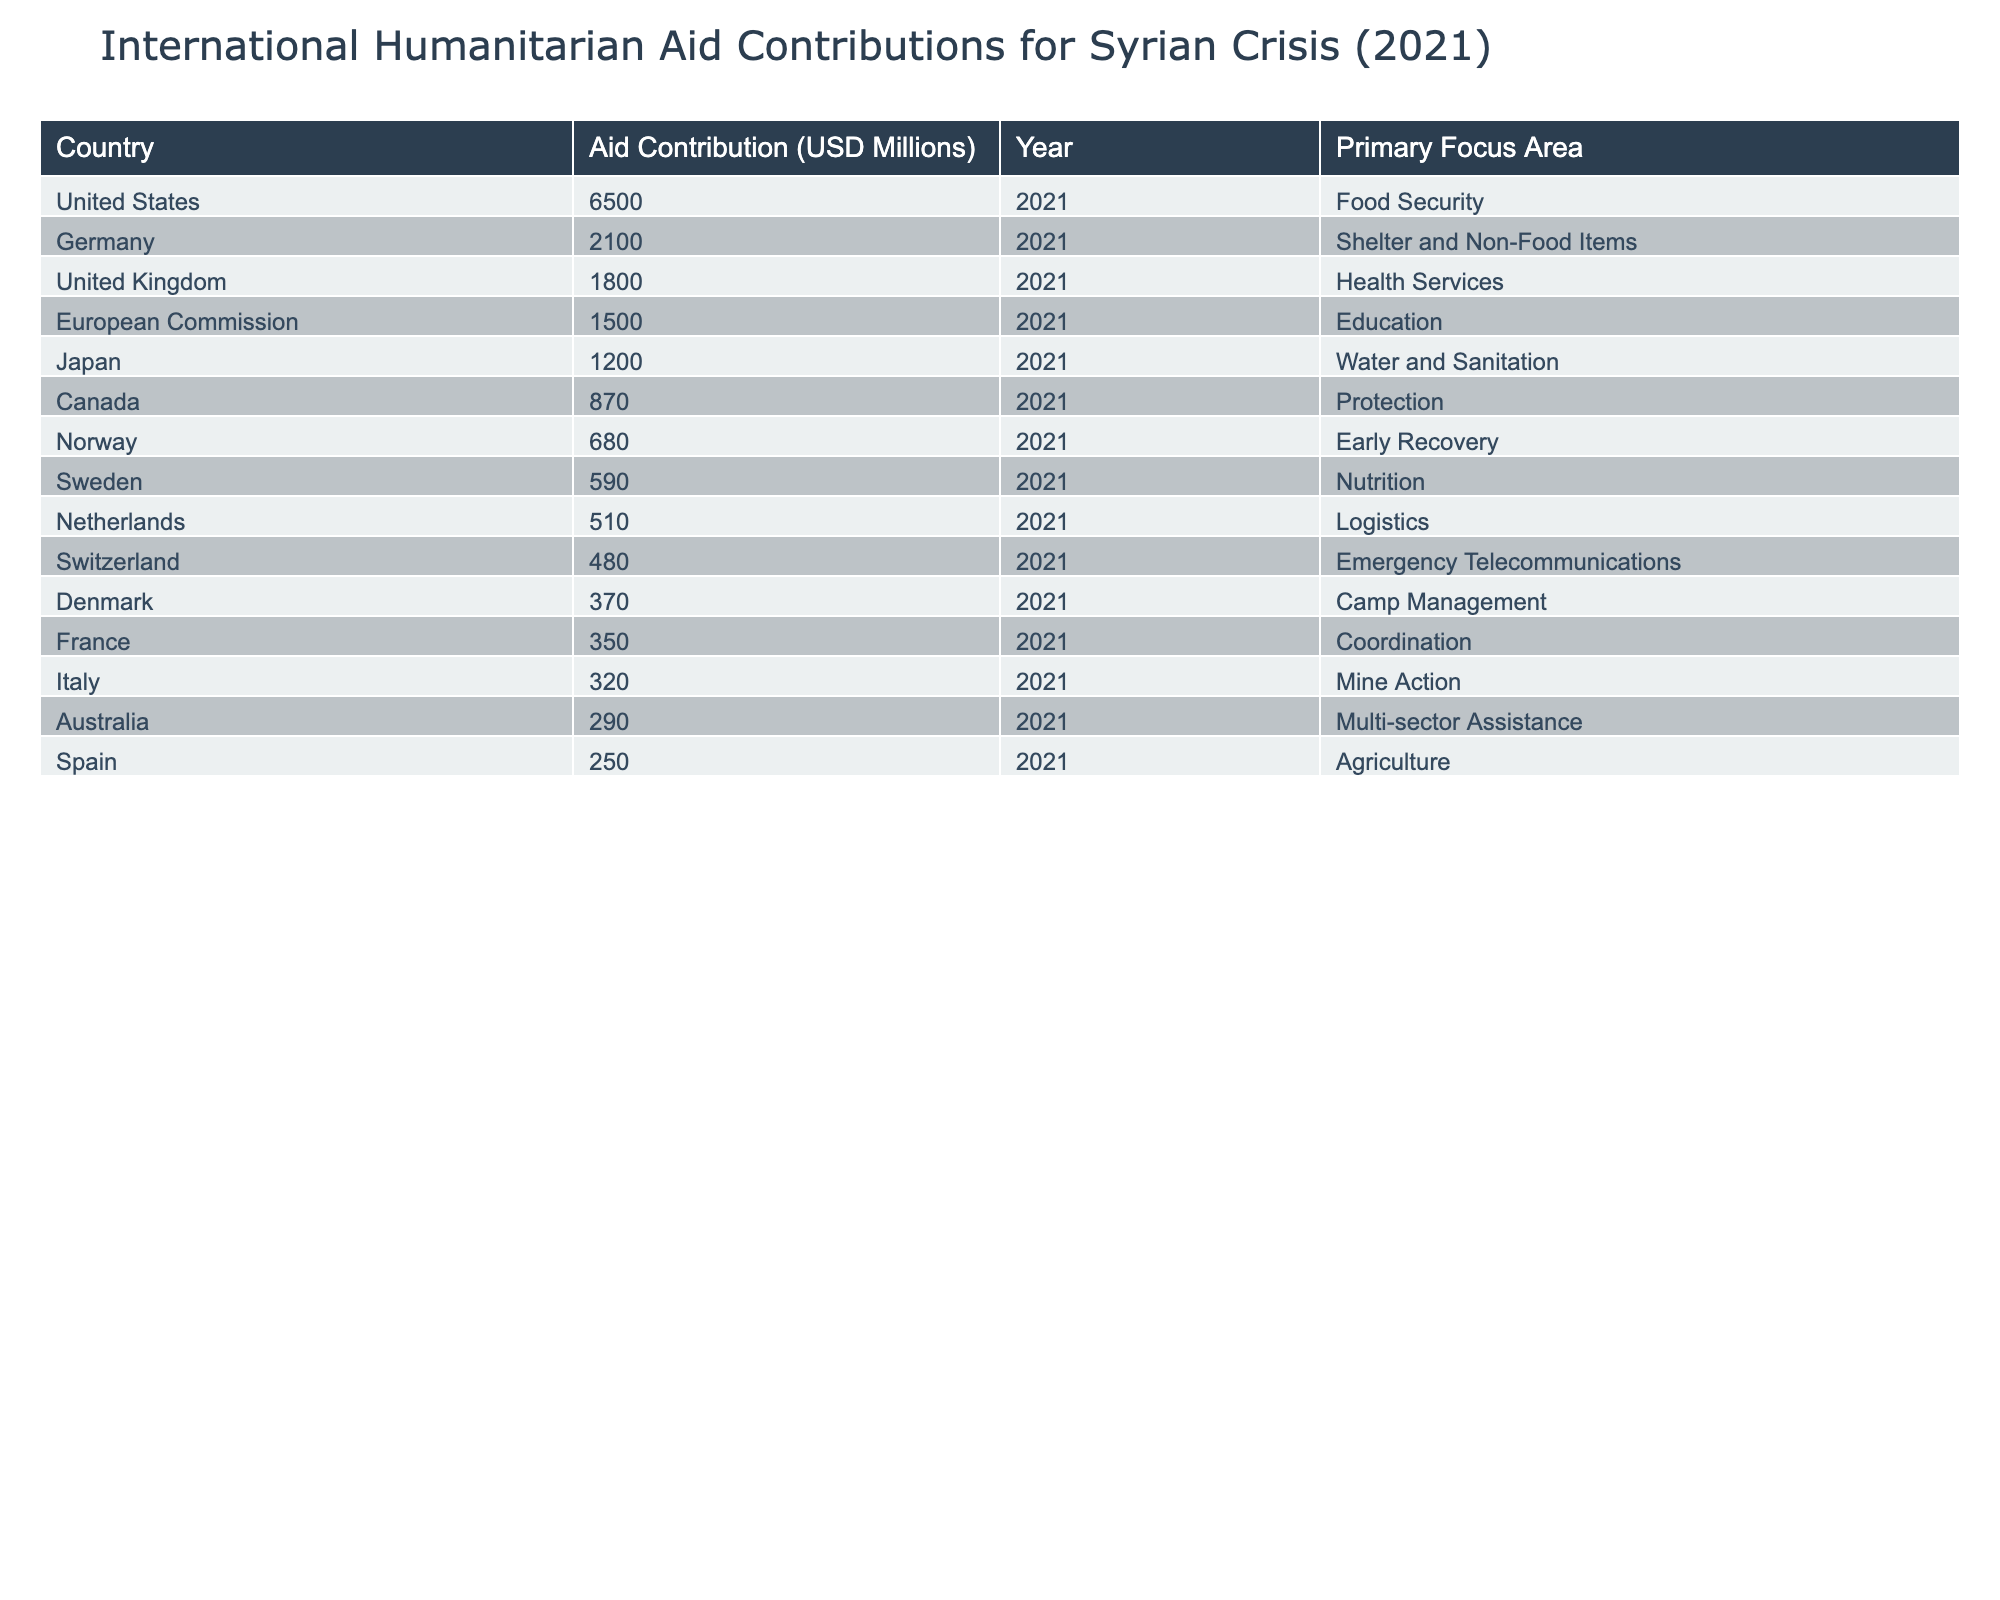What was the total amount of aid contributions from the United States? The table indicates that the United States contributed 6,500 million USD in aid for the Syrian crisis in 2021.
Answer: 6,500 million USD Which country provided the least amount of aid in 2021? Looking at the aid contributions listed, Spain contributed the least with 250 million USD.
Answer: Spain What is the primary focus area for Germany's aid contributions? The data states that Germany's primary focus area for its aid contribution is Shelter and Non-Food Items.
Answer: Shelter and Non-Food Items How much more did the United States contribute compared to the United Kingdom? The United States contributed 6,500 million USD, and the United Kingdom contributed 1,800 million USD. The difference is 6,500 - 1,800 = 4,700 million USD.
Answer: 4,700 million USD What percentage of the total contributions did the European Commission provide? The total contributions from all listed countries sum up to 16,780 million USD (6,500 + 2,100 + 1,800 + 1,500 + 1,200 + 870 + 680 + 590 + 510 + 480 + 370 + 350 + 320 + 290 + 250). The European Commission contributed 1,500 million USD. The percentage is (1,500 / 16,780) * 100 = 8.94%.
Answer: 8.94% Is it true that Norway focused on Education in their aid contributions? The table specifies that Norway's primary focus area is Early Recovery, not Education. Therefore, the statement is false.
Answer: False What is the total aid contribution for all countries focusing on food security and nutrition? The countries focusing on food security (United States) contributed 6,500 million USD, while Sweden focusing on nutrition contributed 590 million USD. The total is 6,500 + 590 = 7,090 million USD.
Answer: 7,090 million USD Which country had an aid contribution greater than 1,000 million USD but less than 2,000 million USD? The countries fitting this criterion are Germany (2,100 million USD) and the United Kingdom (1,800 million USD). Therefore, the only country with a contribution in this range is the United Kingdom at 1,800 million USD.
Answer: United Kingdom How many countries contributed more than 1 billion USD in aid? By counting the contributions, we see that the United States (6,500 million), Germany (2,100 million), the United Kingdom (1,800 million), the European Commission (1,500 million), and Japan (1,200 million) all contributed over 1 billion USD. This totals to five countries.
Answer: 5 What is the combined aid contribution of Canada and Australia? Canada contributed 870 million USD and Australia contributed 290 million USD. Their combined contribution is 870 + 290 = 1,160 million USD.
Answer: 1,160 million USD Which country's contributions can be categorized under multi-sector assistance? According to the table, Australia’s aid contribution is categorized under multi-sector assistance.
Answer: Australia 